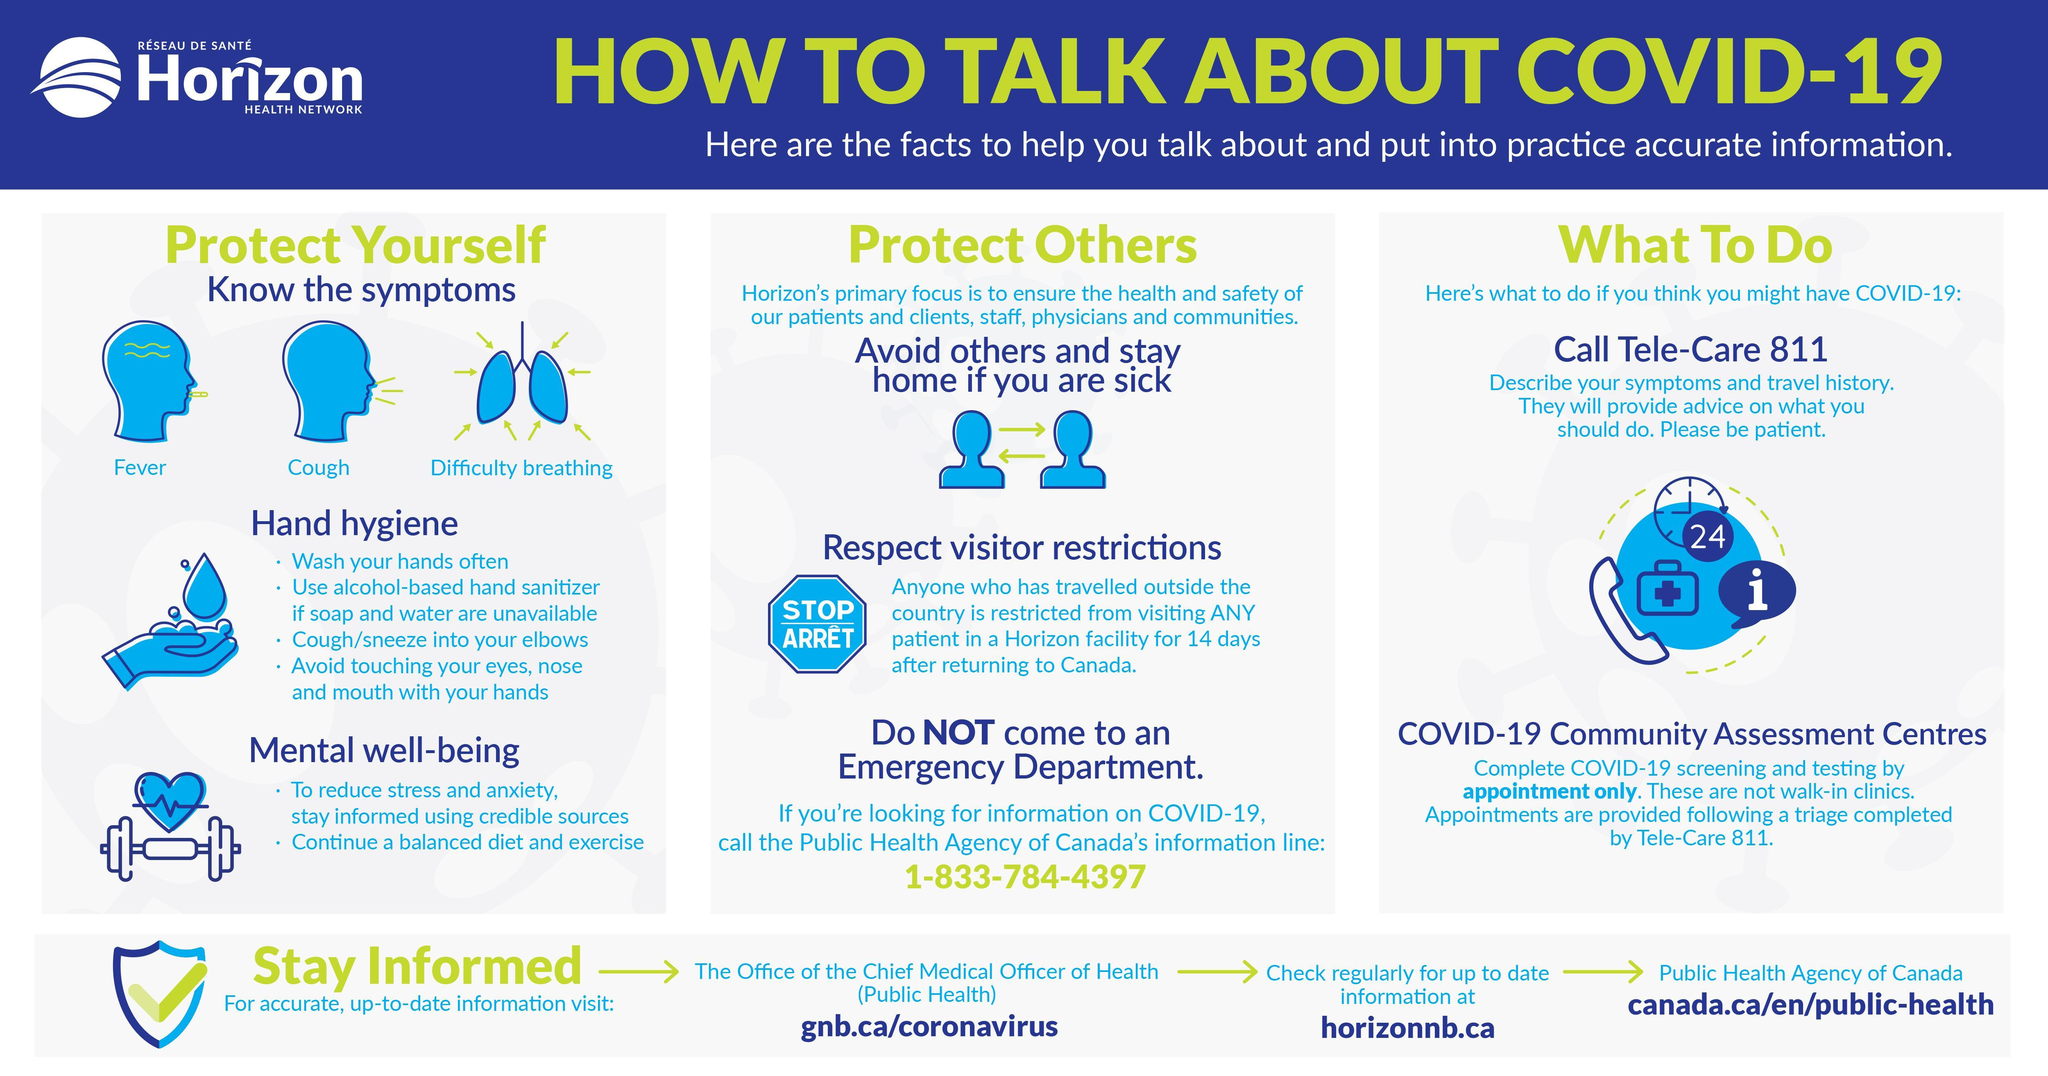How many points are under the heading Hand Hygiene?
Answer the question with a short phrase. 4 What are the symptoms of covid-19? Fever, Cough, Difficulty breathing What is the number written in the clock 24 How many points are under the heading Mental well-being? 2 